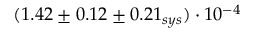<formula> <loc_0><loc_0><loc_500><loc_500>( 1 . 4 2 \pm 0 . 1 2 \pm 0 . 2 1 _ { s y s } ) \cdot 1 0 ^ { - 4 }</formula> 